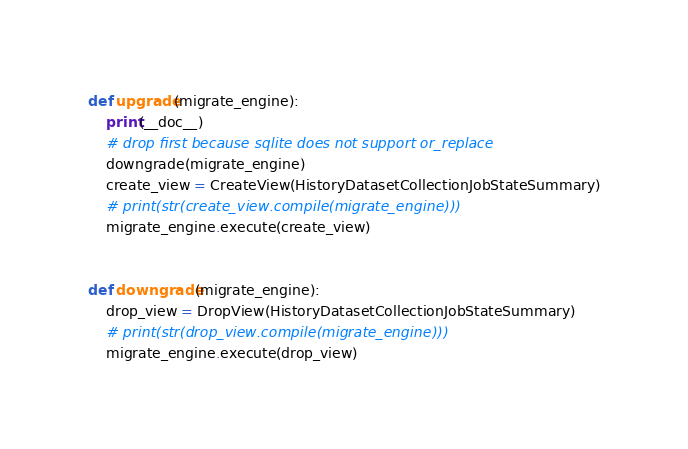<code> <loc_0><loc_0><loc_500><loc_500><_Python_>

def upgrade(migrate_engine):
    print(__doc__)
    # drop first because sqlite does not support or_replace
    downgrade(migrate_engine)
    create_view = CreateView(HistoryDatasetCollectionJobStateSummary)
    # print(str(create_view.compile(migrate_engine)))
    migrate_engine.execute(create_view)


def downgrade(migrate_engine):
    drop_view = DropView(HistoryDatasetCollectionJobStateSummary)
    # print(str(drop_view.compile(migrate_engine)))
    migrate_engine.execute(drop_view)
</code> 